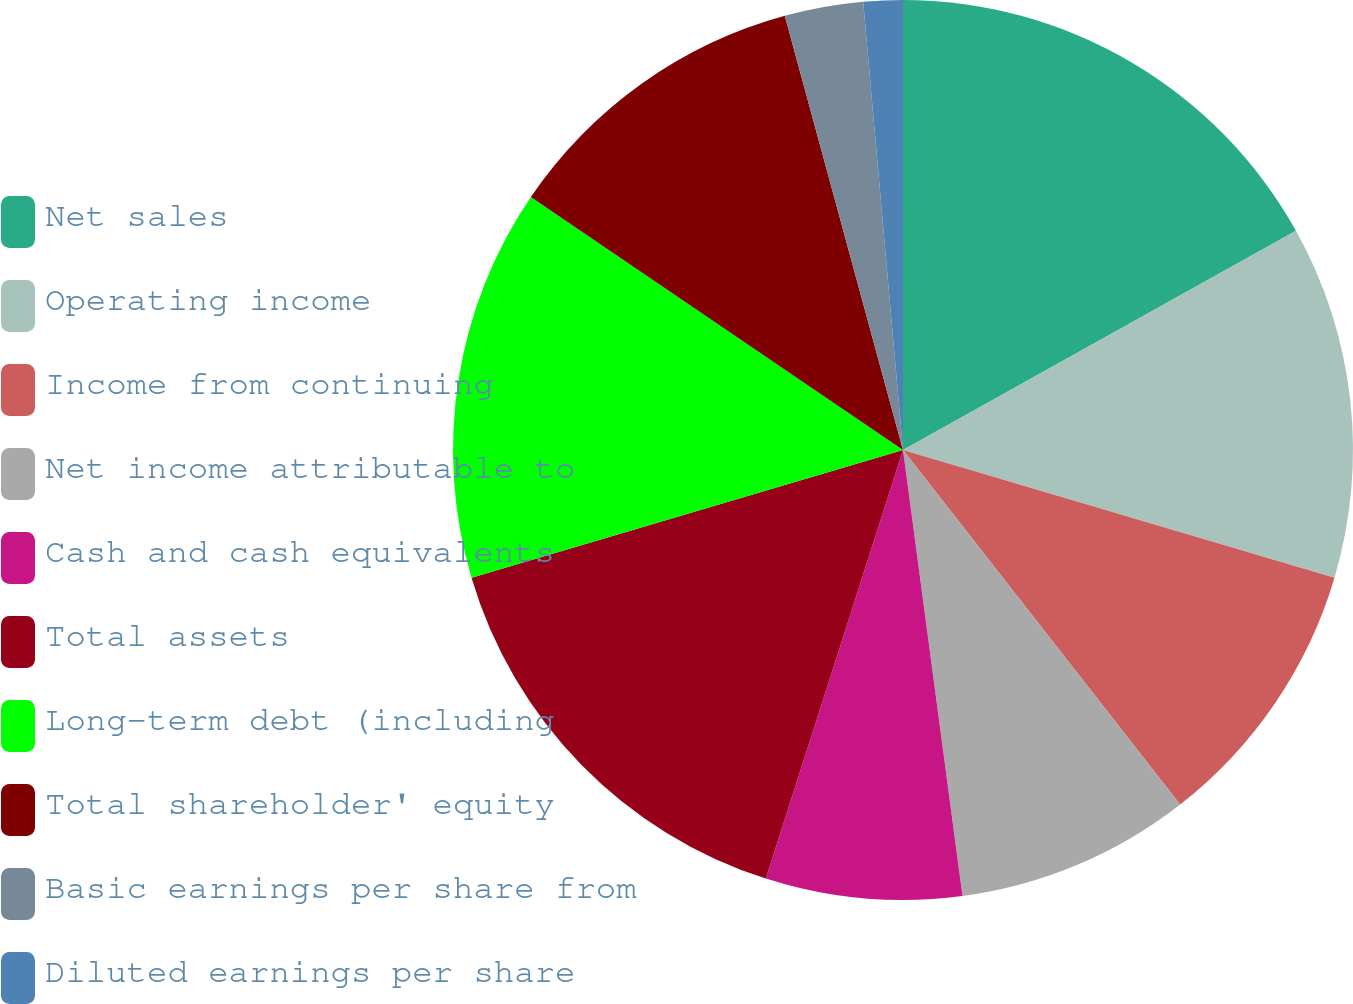Convert chart to OTSL. <chart><loc_0><loc_0><loc_500><loc_500><pie_chart><fcel>Net sales<fcel>Operating income<fcel>Income from continuing<fcel>Net income attributable to<fcel>Cash and cash equivalents<fcel>Total assets<fcel>Long-term debt (including<fcel>Total shareholder' equity<fcel>Basic earnings per share from<fcel>Diluted earnings per share<nl><fcel>16.9%<fcel>12.68%<fcel>9.86%<fcel>8.45%<fcel>7.04%<fcel>15.49%<fcel>14.08%<fcel>11.27%<fcel>2.82%<fcel>1.41%<nl></chart> 